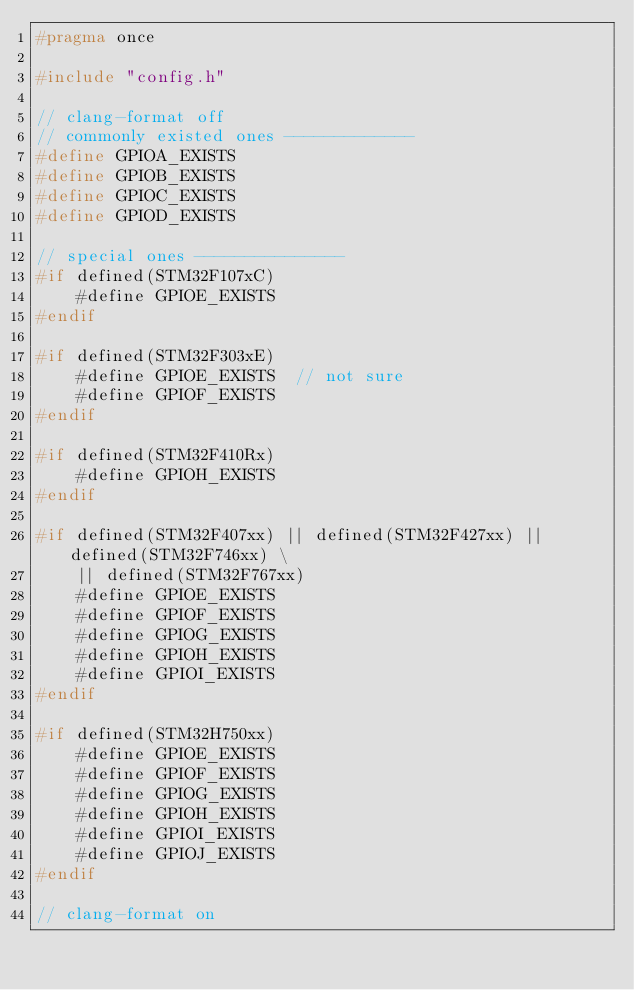Convert code to text. <code><loc_0><loc_0><loc_500><loc_500><_C_>#pragma once

#include "config.h"

// clang-format off
// commonly existed ones -------------
#define GPIOA_EXISTS
#define GPIOB_EXISTS
#define GPIOC_EXISTS
#define GPIOD_EXISTS

// special ones ---------------
#if defined(STM32F107xC)
    #define GPIOE_EXISTS
#endif

#if defined(STM32F303xE)
    #define GPIOE_EXISTS  // not sure
    #define GPIOF_EXISTS
#endif

#if defined(STM32F410Rx)
    #define GPIOH_EXISTS
#endif

#if defined(STM32F407xx) || defined(STM32F427xx) || defined(STM32F746xx) \
    || defined(STM32F767xx)
    #define GPIOE_EXISTS
    #define GPIOF_EXISTS
    #define GPIOG_EXISTS
    #define GPIOH_EXISTS
    #define GPIOI_EXISTS
#endif

#if defined(STM32H750xx)
    #define GPIOE_EXISTS
    #define GPIOF_EXISTS
    #define GPIOG_EXISTS
    #define GPIOH_EXISTS
    #define GPIOI_EXISTS
    #define GPIOJ_EXISTS
#endif

// clang-format on
</code> 